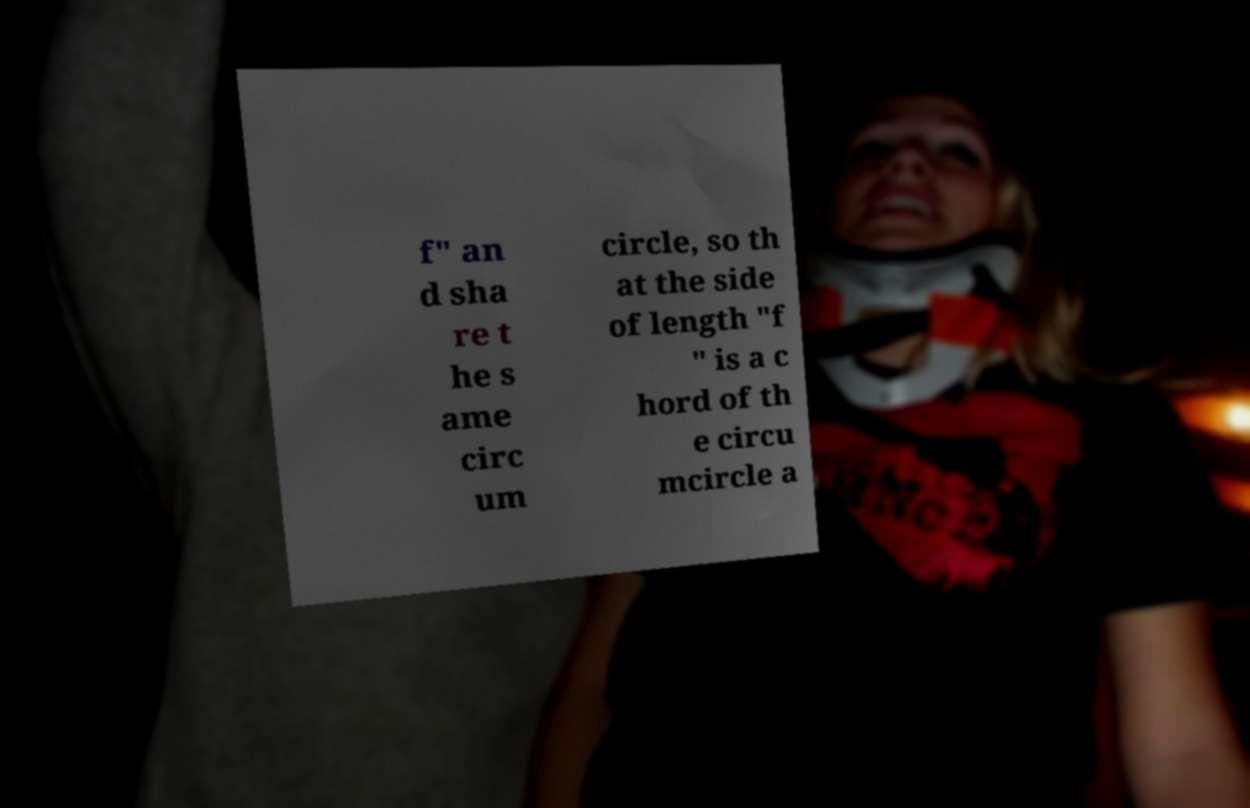Can you accurately transcribe the text from the provided image for me? f" an d sha re t he s ame circ um circle, so th at the side of length "f " is a c hord of th e circu mcircle a 